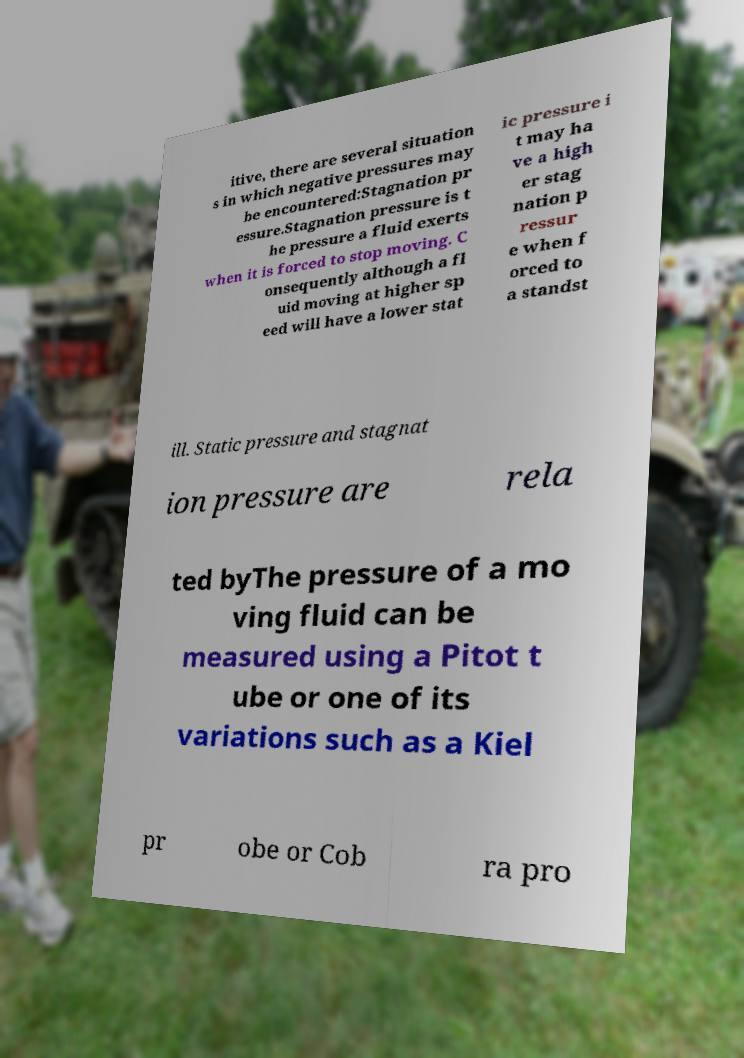Please read and relay the text visible in this image. What does it say? itive, there are several situation s in which negative pressures may be encountered:Stagnation pr essure.Stagnation pressure is t he pressure a fluid exerts when it is forced to stop moving. C onsequently although a fl uid moving at higher sp eed will have a lower stat ic pressure i t may ha ve a high er stag nation p ressur e when f orced to a standst ill. Static pressure and stagnat ion pressure are rela ted byThe pressure of a mo ving fluid can be measured using a Pitot t ube or one of its variations such as a Kiel pr obe or Cob ra pro 